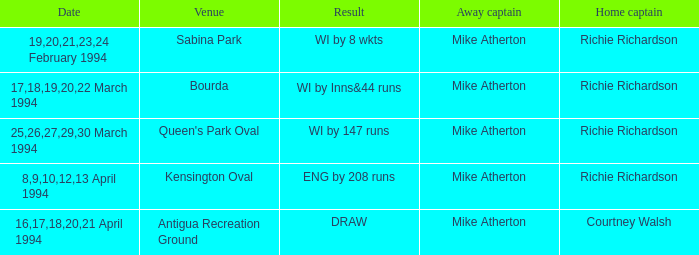Which Home Captain has Venue of Bourda? Richie Richardson. 